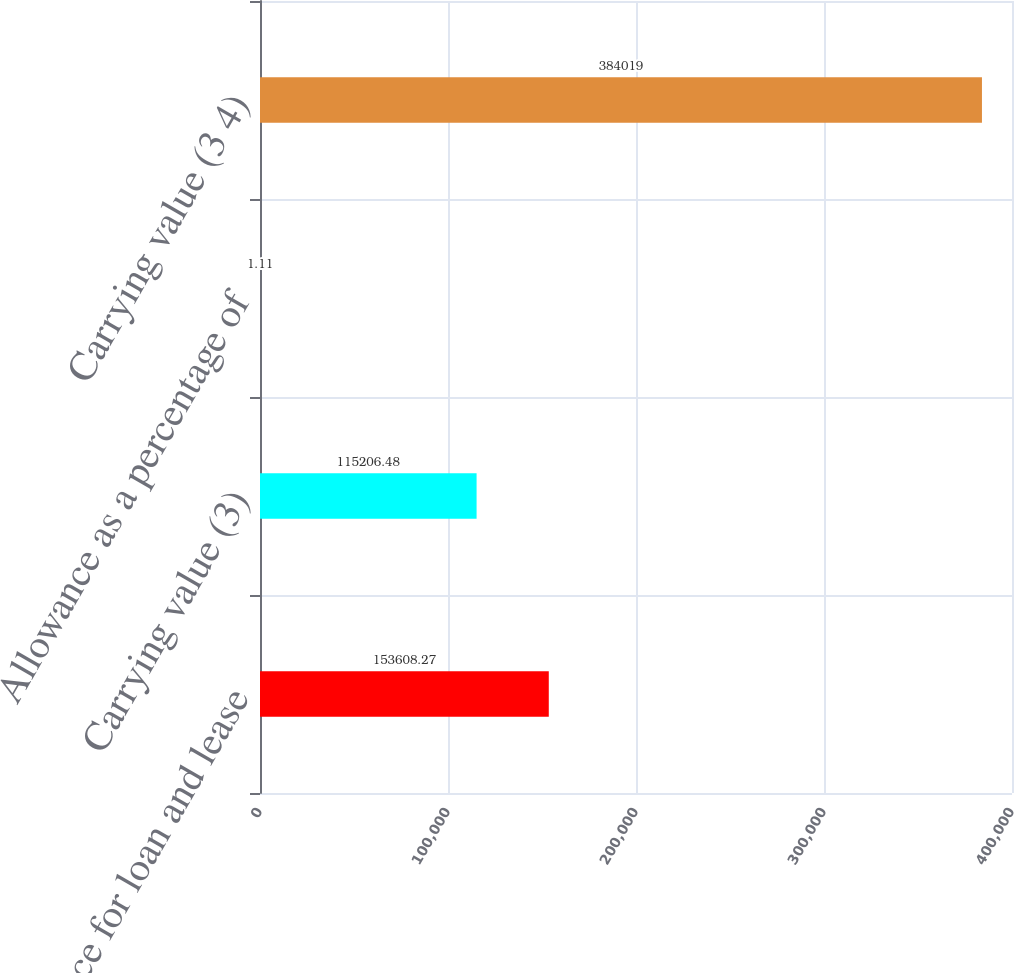Convert chart to OTSL. <chart><loc_0><loc_0><loc_500><loc_500><bar_chart><fcel>Allowance for loan and lease<fcel>Carrying value (3)<fcel>Allowance as a percentage of<fcel>Carrying value (3 4)<nl><fcel>153608<fcel>115206<fcel>1.11<fcel>384019<nl></chart> 